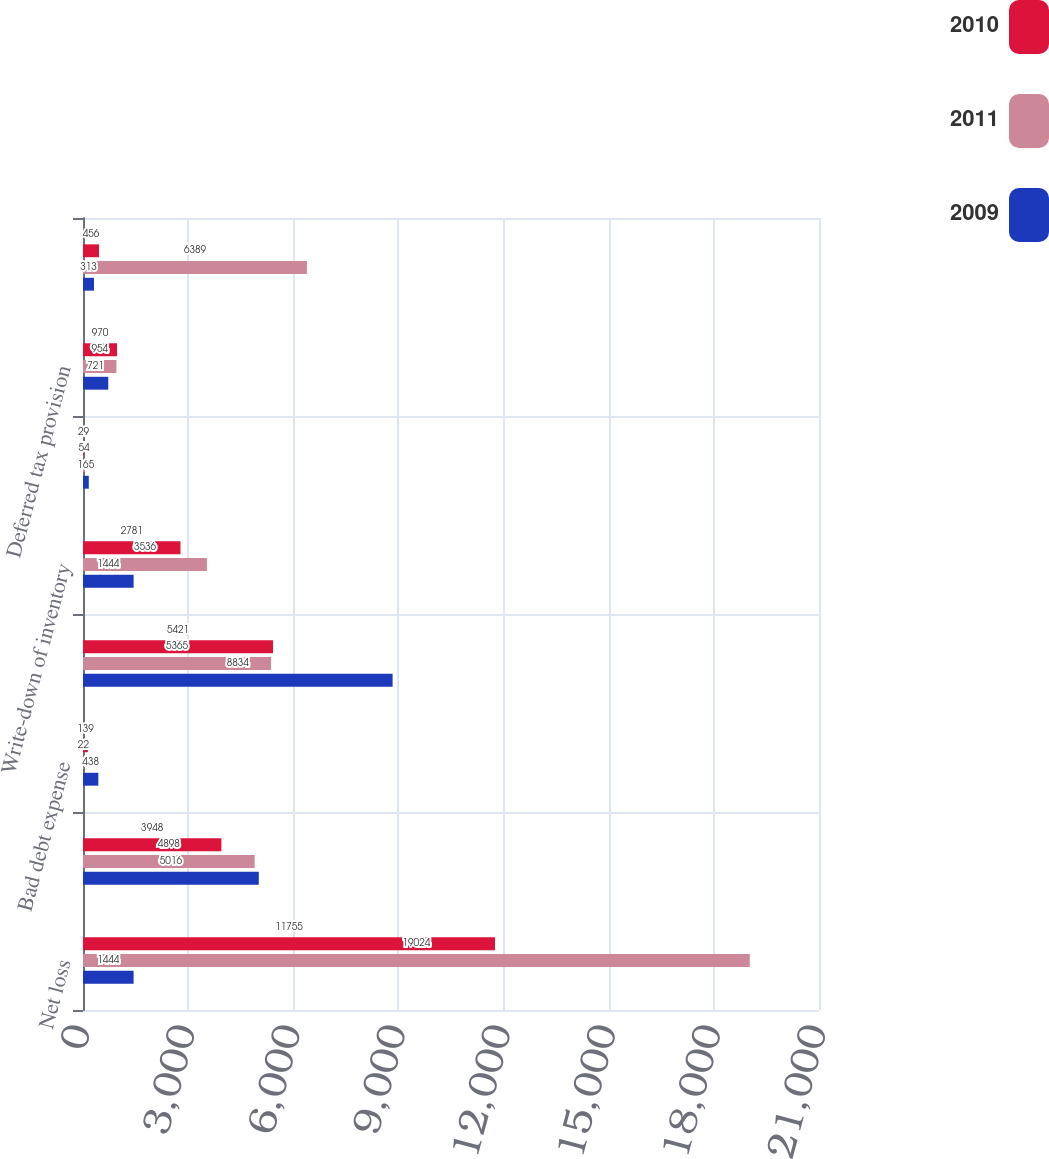Convert chart. <chart><loc_0><loc_0><loc_500><loc_500><stacked_bar_chart><ecel><fcel>Net loss<fcel>Depreciation and amortization<fcel>Bad debt expense<fcel>Stock-based compensation<fcel>Write-down of inventory<fcel>Loss on disposal of fixed<fcel>Deferred tax provision<fcel>Gain on sale of WorldHeart<nl><fcel>2010<fcel>11755<fcel>3948<fcel>139<fcel>5421<fcel>2781<fcel>29<fcel>970<fcel>456<nl><fcel>2011<fcel>19024<fcel>4898<fcel>22<fcel>5365<fcel>3536<fcel>54<fcel>954<fcel>6389<nl><fcel>2009<fcel>1444<fcel>5016<fcel>438<fcel>8834<fcel>1444<fcel>165<fcel>721<fcel>313<nl></chart> 